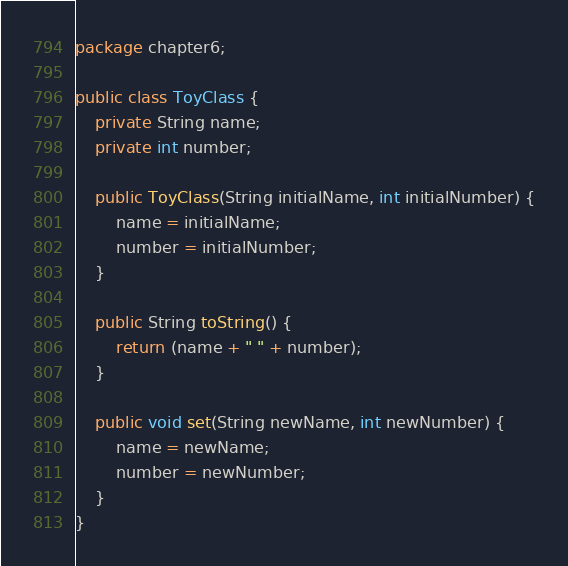<code> <loc_0><loc_0><loc_500><loc_500><_Java_>package chapter6;

public class ToyClass {
	private String name;
	private int number;

	public ToyClass(String initialName, int initialNumber) {
		name = initialName;
		number = initialNumber;
	}

	public String toString() {
		return (name + " " + number);
	}

	public void set(String newName, int newNumber) {
		name = newName;
		number = newNumber;
	}
}
</code> 